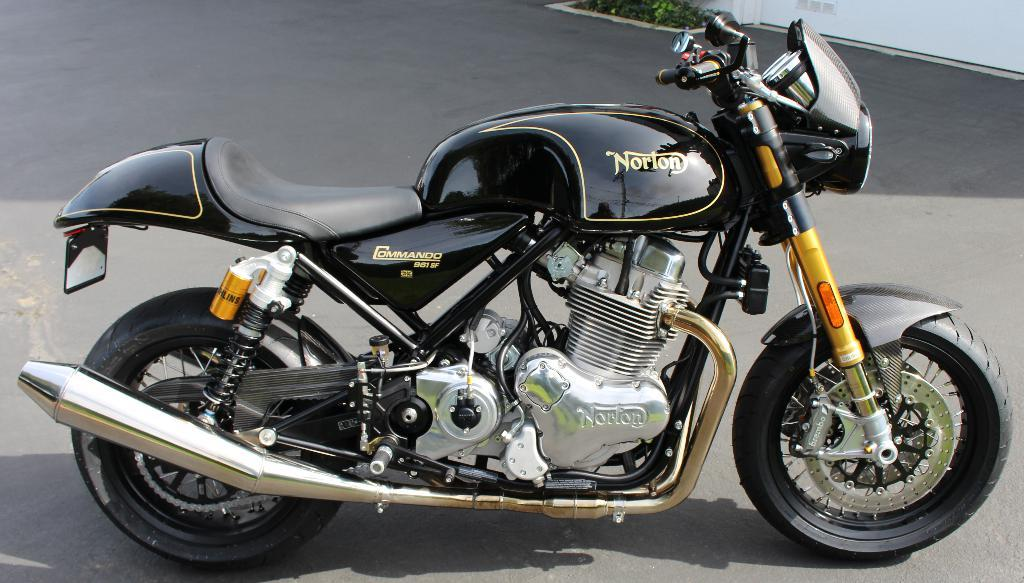What is the main subject of the image? The main subject of the image is a bike. Where is the bike located in the image? The bike is parked on the road in the image. What is the color of the bike? The bike is black in color. What can be seen in the right top of the image? There are plants and a white wall visible in the right top of the image. How many arms are visible on the bike in the image? There are no arms visible on the bike in the image, as it is an inanimate object. What type of calculator can be seen on the bike in the image? There is no calculator present on the bike in the image. 